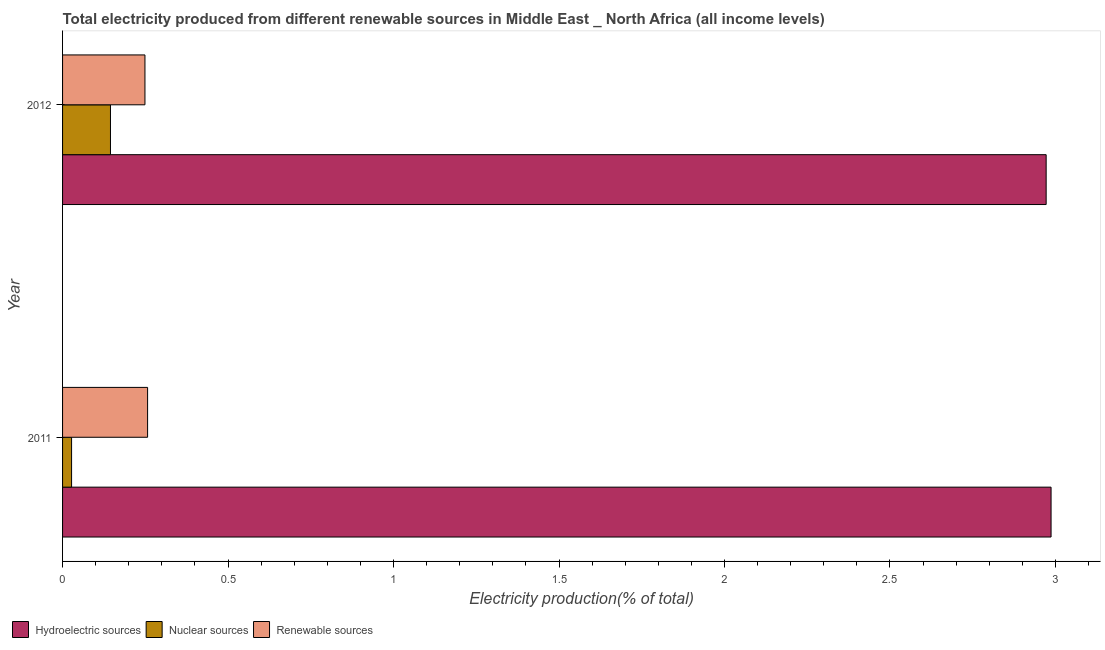How many different coloured bars are there?
Your answer should be compact. 3. Are the number of bars per tick equal to the number of legend labels?
Offer a terse response. Yes. Are the number of bars on each tick of the Y-axis equal?
Provide a succinct answer. Yes. How many bars are there on the 1st tick from the top?
Your response must be concise. 3. How many bars are there on the 1st tick from the bottom?
Provide a short and direct response. 3. In how many cases, is the number of bars for a given year not equal to the number of legend labels?
Your answer should be very brief. 0. What is the percentage of electricity produced by hydroelectric sources in 2011?
Offer a terse response. 2.99. Across all years, what is the maximum percentage of electricity produced by nuclear sources?
Give a very brief answer. 0.14. Across all years, what is the minimum percentage of electricity produced by hydroelectric sources?
Ensure brevity in your answer.  2.97. In which year was the percentage of electricity produced by renewable sources maximum?
Offer a terse response. 2011. What is the total percentage of electricity produced by hydroelectric sources in the graph?
Offer a very short reply. 5.96. What is the difference between the percentage of electricity produced by hydroelectric sources in 2011 and that in 2012?
Offer a terse response. 0.01. What is the difference between the percentage of electricity produced by hydroelectric sources in 2011 and the percentage of electricity produced by renewable sources in 2012?
Give a very brief answer. 2.74. What is the average percentage of electricity produced by nuclear sources per year?
Offer a terse response. 0.09. In the year 2012, what is the difference between the percentage of electricity produced by renewable sources and percentage of electricity produced by nuclear sources?
Offer a very short reply. 0.1. In how many years, is the percentage of electricity produced by hydroelectric sources greater than 2.6 %?
Ensure brevity in your answer.  2. What is the ratio of the percentage of electricity produced by nuclear sources in 2011 to that in 2012?
Offer a very short reply. 0.19. Is the difference between the percentage of electricity produced by hydroelectric sources in 2011 and 2012 greater than the difference between the percentage of electricity produced by renewable sources in 2011 and 2012?
Make the answer very short. Yes. In how many years, is the percentage of electricity produced by renewable sources greater than the average percentage of electricity produced by renewable sources taken over all years?
Give a very brief answer. 1. What does the 3rd bar from the top in 2012 represents?
Give a very brief answer. Hydroelectric sources. What does the 2nd bar from the bottom in 2011 represents?
Offer a very short reply. Nuclear sources. How many bars are there?
Keep it short and to the point. 6. Does the graph contain grids?
Make the answer very short. No. Where does the legend appear in the graph?
Keep it short and to the point. Bottom left. What is the title of the graph?
Your answer should be very brief. Total electricity produced from different renewable sources in Middle East _ North Africa (all income levels). What is the Electricity production(% of total) of Hydroelectric sources in 2011?
Your response must be concise. 2.99. What is the Electricity production(% of total) in Nuclear sources in 2011?
Make the answer very short. 0.03. What is the Electricity production(% of total) in Renewable sources in 2011?
Make the answer very short. 0.26. What is the Electricity production(% of total) in Hydroelectric sources in 2012?
Keep it short and to the point. 2.97. What is the Electricity production(% of total) in Nuclear sources in 2012?
Keep it short and to the point. 0.14. What is the Electricity production(% of total) in Renewable sources in 2012?
Your answer should be compact. 0.25. Across all years, what is the maximum Electricity production(% of total) in Hydroelectric sources?
Provide a short and direct response. 2.99. Across all years, what is the maximum Electricity production(% of total) in Nuclear sources?
Offer a very short reply. 0.14. Across all years, what is the maximum Electricity production(% of total) of Renewable sources?
Your response must be concise. 0.26. Across all years, what is the minimum Electricity production(% of total) in Hydroelectric sources?
Your answer should be compact. 2.97. Across all years, what is the minimum Electricity production(% of total) of Nuclear sources?
Provide a succinct answer. 0.03. Across all years, what is the minimum Electricity production(% of total) in Renewable sources?
Your answer should be very brief. 0.25. What is the total Electricity production(% of total) in Hydroelectric sources in the graph?
Your answer should be very brief. 5.96. What is the total Electricity production(% of total) in Nuclear sources in the graph?
Keep it short and to the point. 0.17. What is the total Electricity production(% of total) of Renewable sources in the graph?
Your response must be concise. 0.51. What is the difference between the Electricity production(% of total) in Hydroelectric sources in 2011 and that in 2012?
Keep it short and to the point. 0.01. What is the difference between the Electricity production(% of total) in Nuclear sources in 2011 and that in 2012?
Your response must be concise. -0.12. What is the difference between the Electricity production(% of total) in Renewable sources in 2011 and that in 2012?
Offer a terse response. 0.01. What is the difference between the Electricity production(% of total) in Hydroelectric sources in 2011 and the Electricity production(% of total) in Nuclear sources in 2012?
Your answer should be very brief. 2.84. What is the difference between the Electricity production(% of total) of Hydroelectric sources in 2011 and the Electricity production(% of total) of Renewable sources in 2012?
Offer a terse response. 2.74. What is the difference between the Electricity production(% of total) of Nuclear sources in 2011 and the Electricity production(% of total) of Renewable sources in 2012?
Offer a very short reply. -0.22. What is the average Electricity production(% of total) in Hydroelectric sources per year?
Your answer should be very brief. 2.98. What is the average Electricity production(% of total) in Nuclear sources per year?
Your answer should be compact. 0.09. What is the average Electricity production(% of total) in Renewable sources per year?
Provide a short and direct response. 0.25. In the year 2011, what is the difference between the Electricity production(% of total) of Hydroelectric sources and Electricity production(% of total) of Nuclear sources?
Give a very brief answer. 2.96. In the year 2011, what is the difference between the Electricity production(% of total) of Hydroelectric sources and Electricity production(% of total) of Renewable sources?
Your answer should be compact. 2.73. In the year 2011, what is the difference between the Electricity production(% of total) in Nuclear sources and Electricity production(% of total) in Renewable sources?
Your answer should be very brief. -0.23. In the year 2012, what is the difference between the Electricity production(% of total) in Hydroelectric sources and Electricity production(% of total) in Nuclear sources?
Give a very brief answer. 2.83. In the year 2012, what is the difference between the Electricity production(% of total) of Hydroelectric sources and Electricity production(% of total) of Renewable sources?
Provide a short and direct response. 2.72. In the year 2012, what is the difference between the Electricity production(% of total) of Nuclear sources and Electricity production(% of total) of Renewable sources?
Your response must be concise. -0.1. What is the ratio of the Electricity production(% of total) of Hydroelectric sources in 2011 to that in 2012?
Keep it short and to the point. 1. What is the ratio of the Electricity production(% of total) of Nuclear sources in 2011 to that in 2012?
Ensure brevity in your answer.  0.19. What is the ratio of the Electricity production(% of total) in Renewable sources in 2011 to that in 2012?
Keep it short and to the point. 1.03. What is the difference between the highest and the second highest Electricity production(% of total) of Hydroelectric sources?
Make the answer very short. 0.01. What is the difference between the highest and the second highest Electricity production(% of total) in Nuclear sources?
Your answer should be very brief. 0.12. What is the difference between the highest and the second highest Electricity production(% of total) of Renewable sources?
Keep it short and to the point. 0.01. What is the difference between the highest and the lowest Electricity production(% of total) in Hydroelectric sources?
Your answer should be compact. 0.01. What is the difference between the highest and the lowest Electricity production(% of total) in Nuclear sources?
Keep it short and to the point. 0.12. What is the difference between the highest and the lowest Electricity production(% of total) in Renewable sources?
Your answer should be compact. 0.01. 